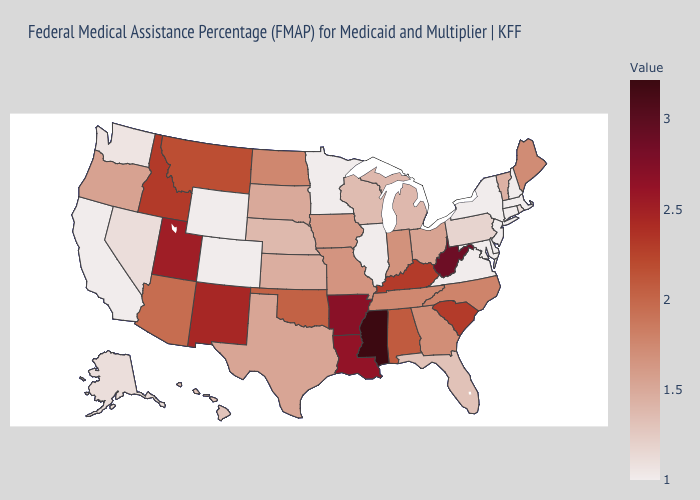Which states have the lowest value in the West?
Be succinct. California, Colorado, Wyoming. Among the states that border Delaware , which have the highest value?
Be succinct. Pennsylvania. Which states have the lowest value in the USA?
Quick response, please. California, Colorado, Connecticut, Delaware, Illinois, Maryland, Massachusetts, Minnesota, New Hampshire, New Jersey, New York, Virginia, Wyoming. Is the legend a continuous bar?
Keep it brief. Yes. Among the states that border Alabama , which have the highest value?
Keep it brief. Mississippi. Which states hav the highest value in the West?
Give a very brief answer. Utah. Which states have the lowest value in the USA?
Keep it brief. California, Colorado, Connecticut, Delaware, Illinois, Maryland, Massachusetts, Minnesota, New Hampshire, New Jersey, New York, Virginia, Wyoming. Which states hav the highest value in the South?
Concise answer only. Mississippi. 